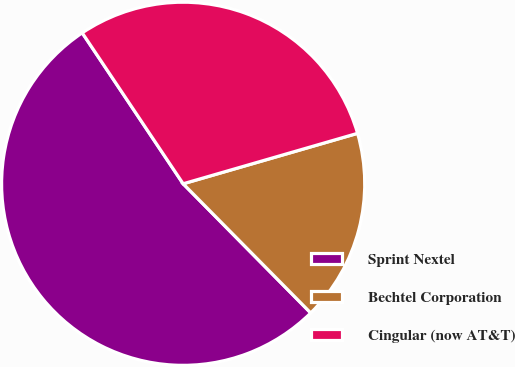Convert chart. <chart><loc_0><loc_0><loc_500><loc_500><pie_chart><fcel>Sprint Nextel<fcel>Bechtel Corporation<fcel>Cingular (now AT&T)<nl><fcel>53.02%<fcel>17.08%<fcel>29.9%<nl></chart> 